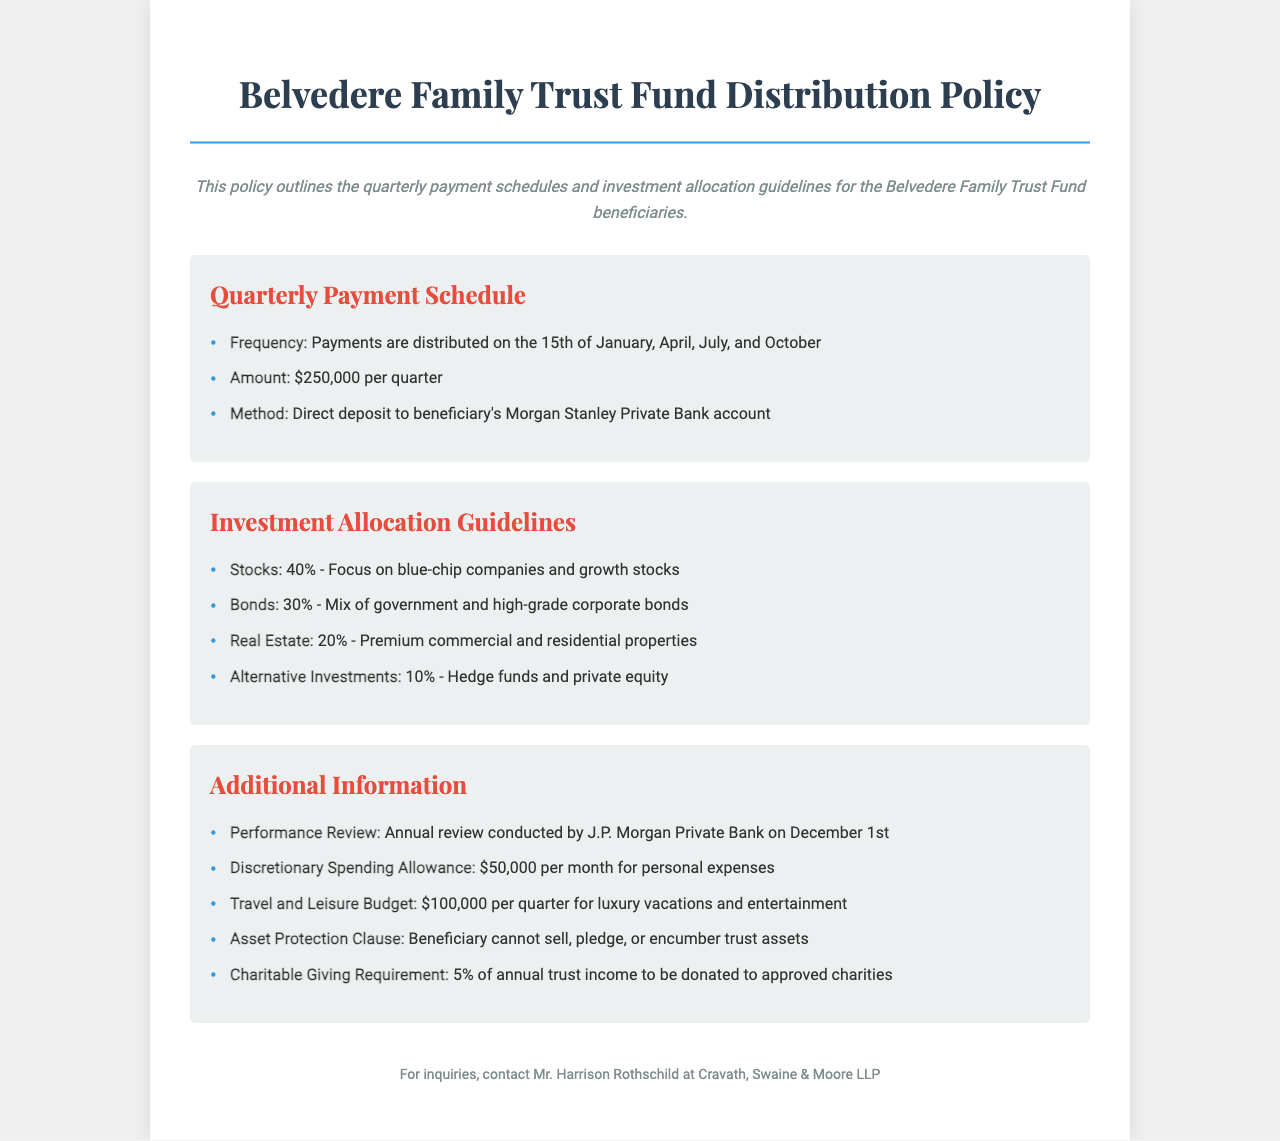what is the quarterly payment amount? The quarterly payment amount is specified in the document as $250,000 per quarter.
Answer: $250,000 when are payments distributed? Payments are distributed on specific dates detailed in the document. The payment dates are January 15, April 15, July 15, and October 15.
Answer: January 15, April 15, July 15, October 15 what is the discretionary spending allowance? The discretionary spending allowance is stated in the document as a monthly allowance for personal expenses.
Answer: $50,000 what percentage of the investment is allocated to bonds? The document provides allocation percentages for different investment types, including bonds. The allocation for bonds is specified as 30%.
Answer: 30% who conducts the annual performance review? The document mentions that a review is conducted by a specific financial institution on December 1st.
Answer: J.P. Morgan Private Bank what is the travel and leisure budget per quarter? The budget for luxury vacations and entertainment is mentioned in terms of quarterly finances.
Answer: $100,000 what is the asset protection clause about? The document states specific terms related to trust assets. The protection clause prohibits certain actions regarding trust assets.
Answer: Beneficiary cannot sell, pledge, or encumber trust assets what is the percentage of annual trust income required for charitable giving? The policy outlines a specific percentage of the trust income that must be donated to charities.
Answer: 5% 